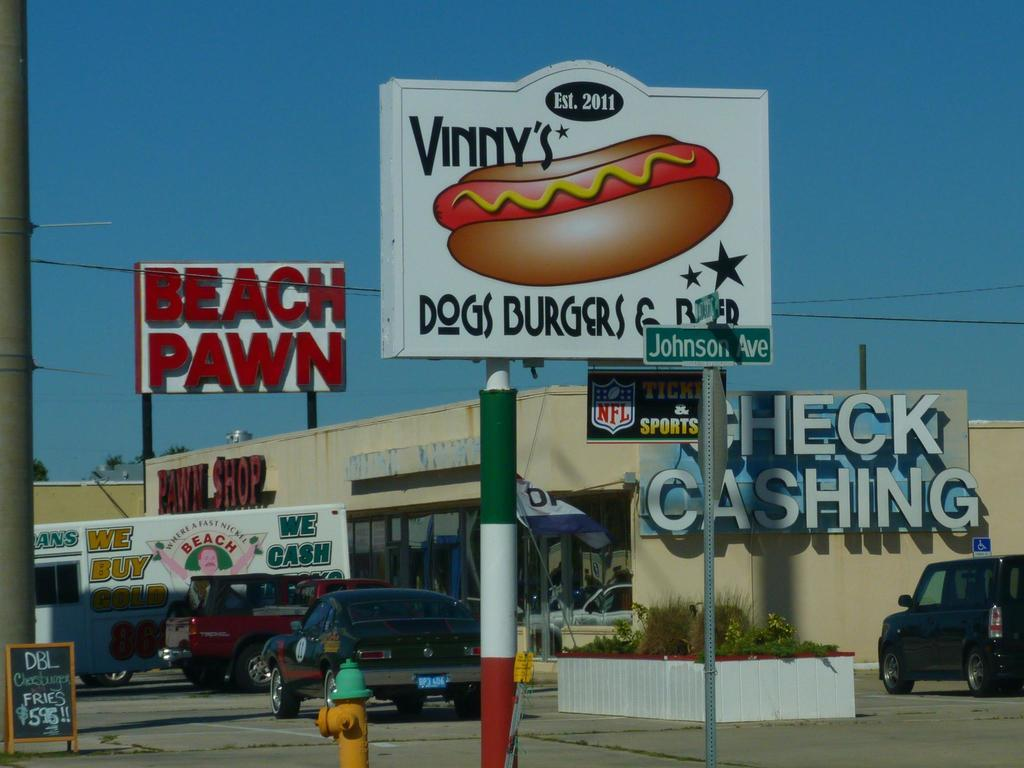Provide a one-sentence caption for the provided image. The pawn shop next to the the ad for Vinny's dogs. 